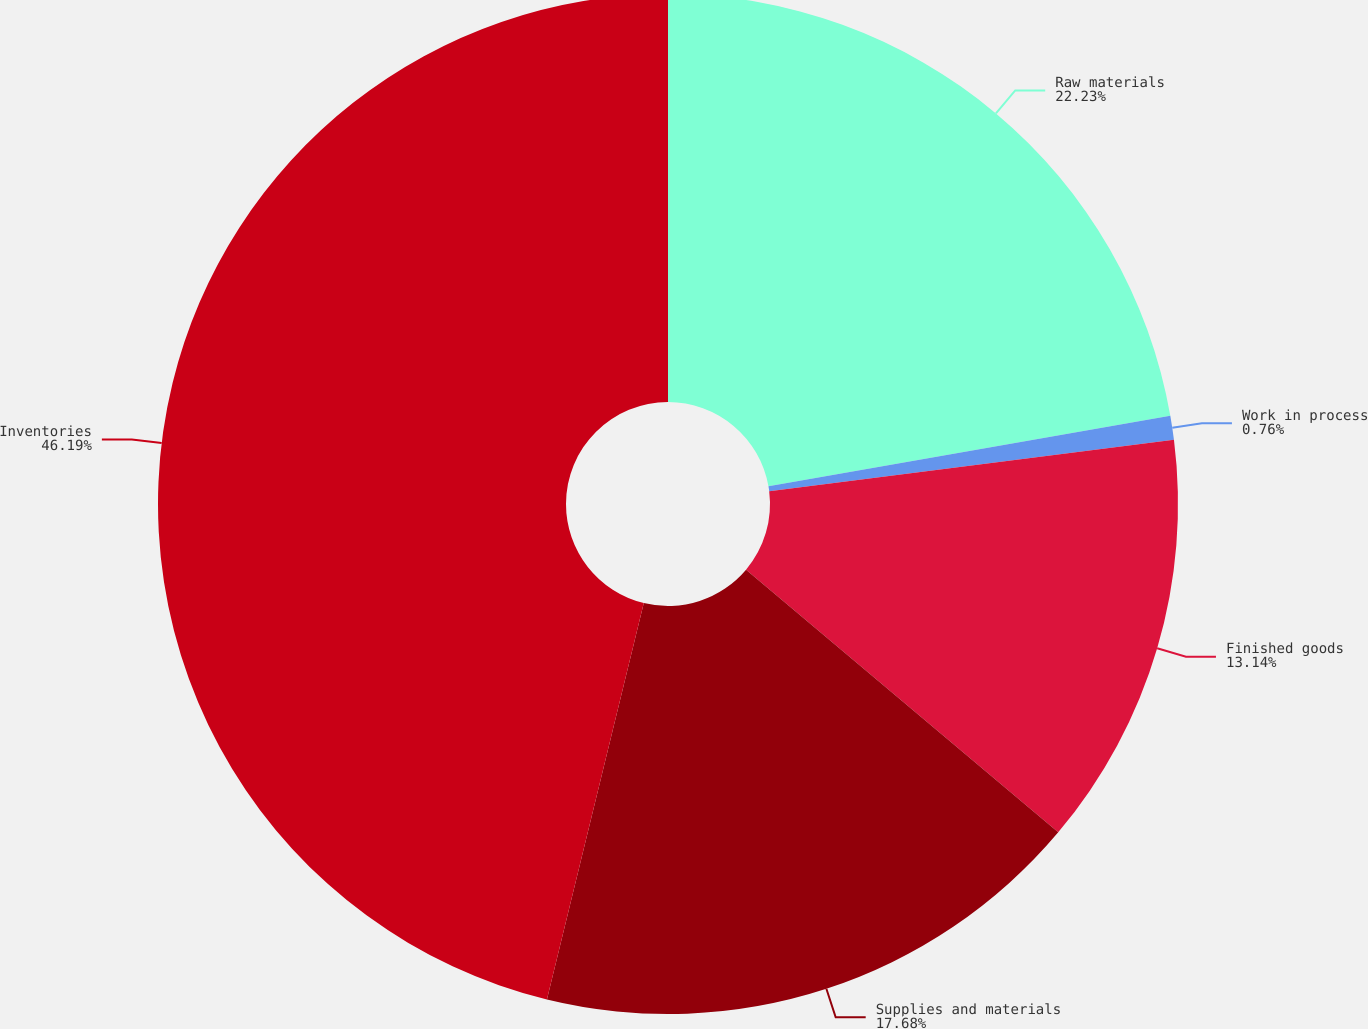Convert chart. <chart><loc_0><loc_0><loc_500><loc_500><pie_chart><fcel>Raw materials<fcel>Work in process<fcel>Finished goods<fcel>Supplies and materials<fcel>Inventories<nl><fcel>22.23%<fcel>0.76%<fcel>13.14%<fcel>17.68%<fcel>46.18%<nl></chart> 